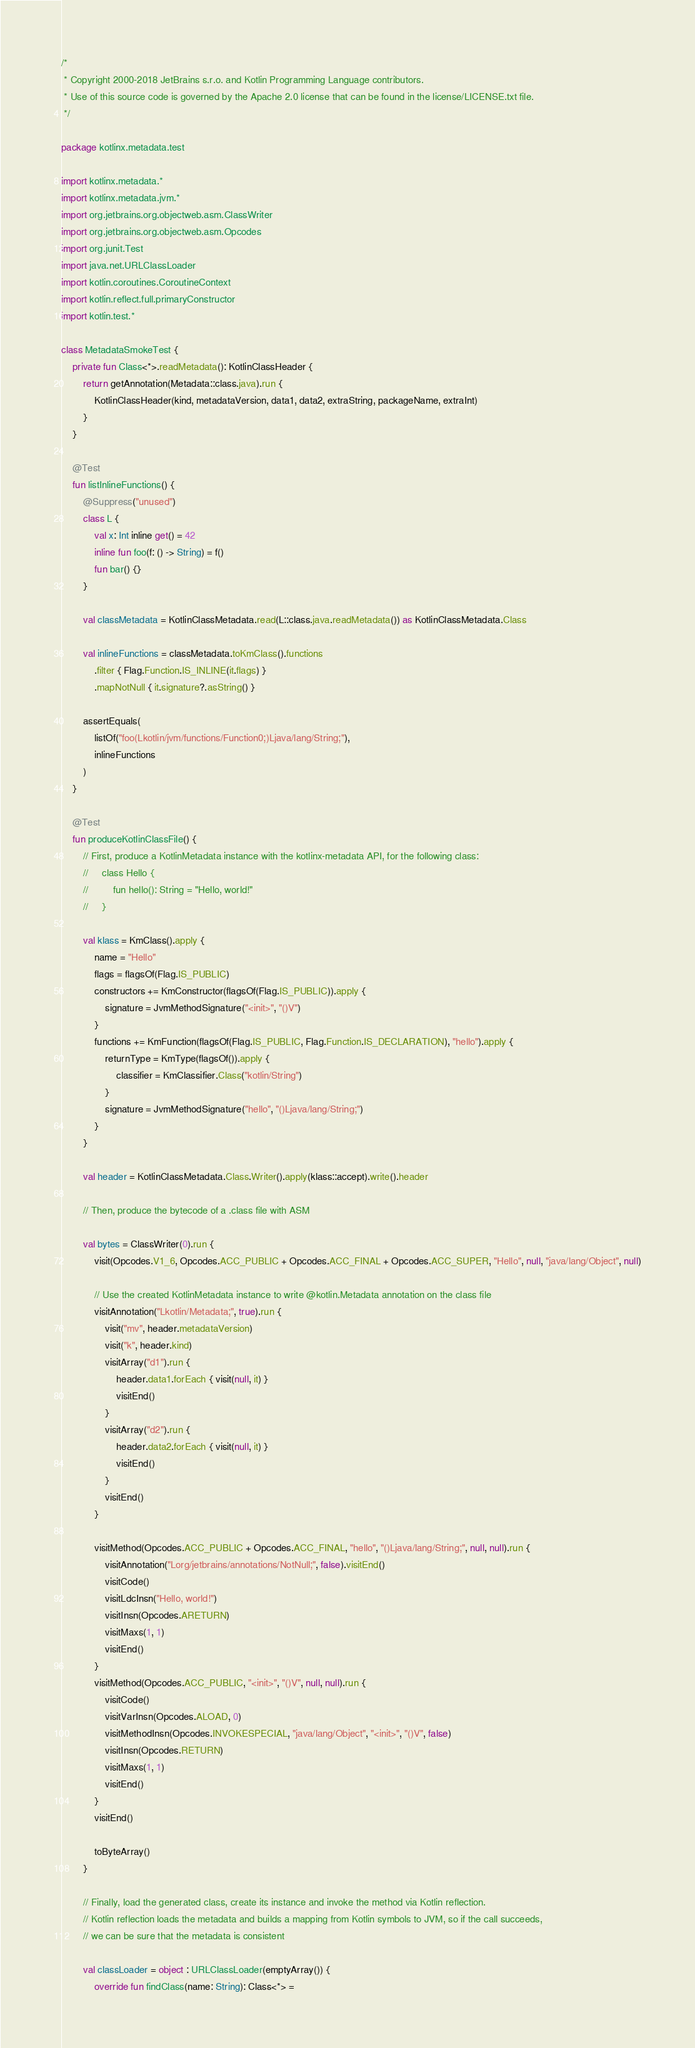<code> <loc_0><loc_0><loc_500><loc_500><_Kotlin_>/*
 * Copyright 2000-2018 JetBrains s.r.o. and Kotlin Programming Language contributors.
 * Use of this source code is governed by the Apache 2.0 license that can be found in the license/LICENSE.txt file.
 */

package kotlinx.metadata.test

import kotlinx.metadata.*
import kotlinx.metadata.jvm.*
import org.jetbrains.org.objectweb.asm.ClassWriter
import org.jetbrains.org.objectweb.asm.Opcodes
import org.junit.Test
import java.net.URLClassLoader
import kotlin.coroutines.CoroutineContext
import kotlin.reflect.full.primaryConstructor
import kotlin.test.*

class MetadataSmokeTest {
    private fun Class<*>.readMetadata(): KotlinClassHeader {
        return getAnnotation(Metadata::class.java).run {
            KotlinClassHeader(kind, metadataVersion, data1, data2, extraString, packageName, extraInt)
        }
    }

    @Test
    fun listInlineFunctions() {
        @Suppress("unused")
        class L {
            val x: Int inline get() = 42
            inline fun foo(f: () -> String) = f()
            fun bar() {}
        }

        val classMetadata = KotlinClassMetadata.read(L::class.java.readMetadata()) as KotlinClassMetadata.Class

        val inlineFunctions = classMetadata.toKmClass().functions
            .filter { Flag.Function.IS_INLINE(it.flags) }
            .mapNotNull { it.signature?.asString() }

        assertEquals(
            listOf("foo(Lkotlin/jvm/functions/Function0;)Ljava/lang/String;"),
            inlineFunctions
        )
    }

    @Test
    fun produceKotlinClassFile() {
        // First, produce a KotlinMetadata instance with the kotlinx-metadata API, for the following class:
        //     class Hello {
        //         fun hello(): String = "Hello, world!"
        //     }

        val klass = KmClass().apply {
            name = "Hello"
            flags = flagsOf(Flag.IS_PUBLIC)
            constructors += KmConstructor(flagsOf(Flag.IS_PUBLIC)).apply {
                signature = JvmMethodSignature("<init>", "()V")
            }
            functions += KmFunction(flagsOf(Flag.IS_PUBLIC, Flag.Function.IS_DECLARATION), "hello").apply {
                returnType = KmType(flagsOf()).apply {
                    classifier = KmClassifier.Class("kotlin/String")
                }
                signature = JvmMethodSignature("hello", "()Ljava/lang/String;")
            }
        }

        val header = KotlinClassMetadata.Class.Writer().apply(klass::accept).write().header

        // Then, produce the bytecode of a .class file with ASM

        val bytes = ClassWriter(0).run {
            visit(Opcodes.V1_6, Opcodes.ACC_PUBLIC + Opcodes.ACC_FINAL + Opcodes.ACC_SUPER, "Hello", null, "java/lang/Object", null)

            // Use the created KotlinMetadata instance to write @kotlin.Metadata annotation on the class file
            visitAnnotation("Lkotlin/Metadata;", true).run {
                visit("mv", header.metadataVersion)
                visit("k", header.kind)
                visitArray("d1").run {
                    header.data1.forEach { visit(null, it) }
                    visitEnd()
                }
                visitArray("d2").run {
                    header.data2.forEach { visit(null, it) }
                    visitEnd()
                }
                visitEnd()
            }

            visitMethod(Opcodes.ACC_PUBLIC + Opcodes.ACC_FINAL, "hello", "()Ljava/lang/String;", null, null).run {
                visitAnnotation("Lorg/jetbrains/annotations/NotNull;", false).visitEnd()
                visitCode()
                visitLdcInsn("Hello, world!")
                visitInsn(Opcodes.ARETURN)
                visitMaxs(1, 1)
                visitEnd()
            }
            visitMethod(Opcodes.ACC_PUBLIC, "<init>", "()V", null, null).run {
                visitCode()
                visitVarInsn(Opcodes.ALOAD, 0)
                visitMethodInsn(Opcodes.INVOKESPECIAL, "java/lang/Object", "<init>", "()V", false)
                visitInsn(Opcodes.RETURN)
                visitMaxs(1, 1)
                visitEnd()
            }
            visitEnd()

            toByteArray()
        }

        // Finally, load the generated class, create its instance and invoke the method via Kotlin reflection.
        // Kotlin reflection loads the metadata and builds a mapping from Kotlin symbols to JVM, so if the call succeeds,
        // we can be sure that the metadata is consistent

        val classLoader = object : URLClassLoader(emptyArray()) {
            override fun findClass(name: String): Class<*> =</code> 